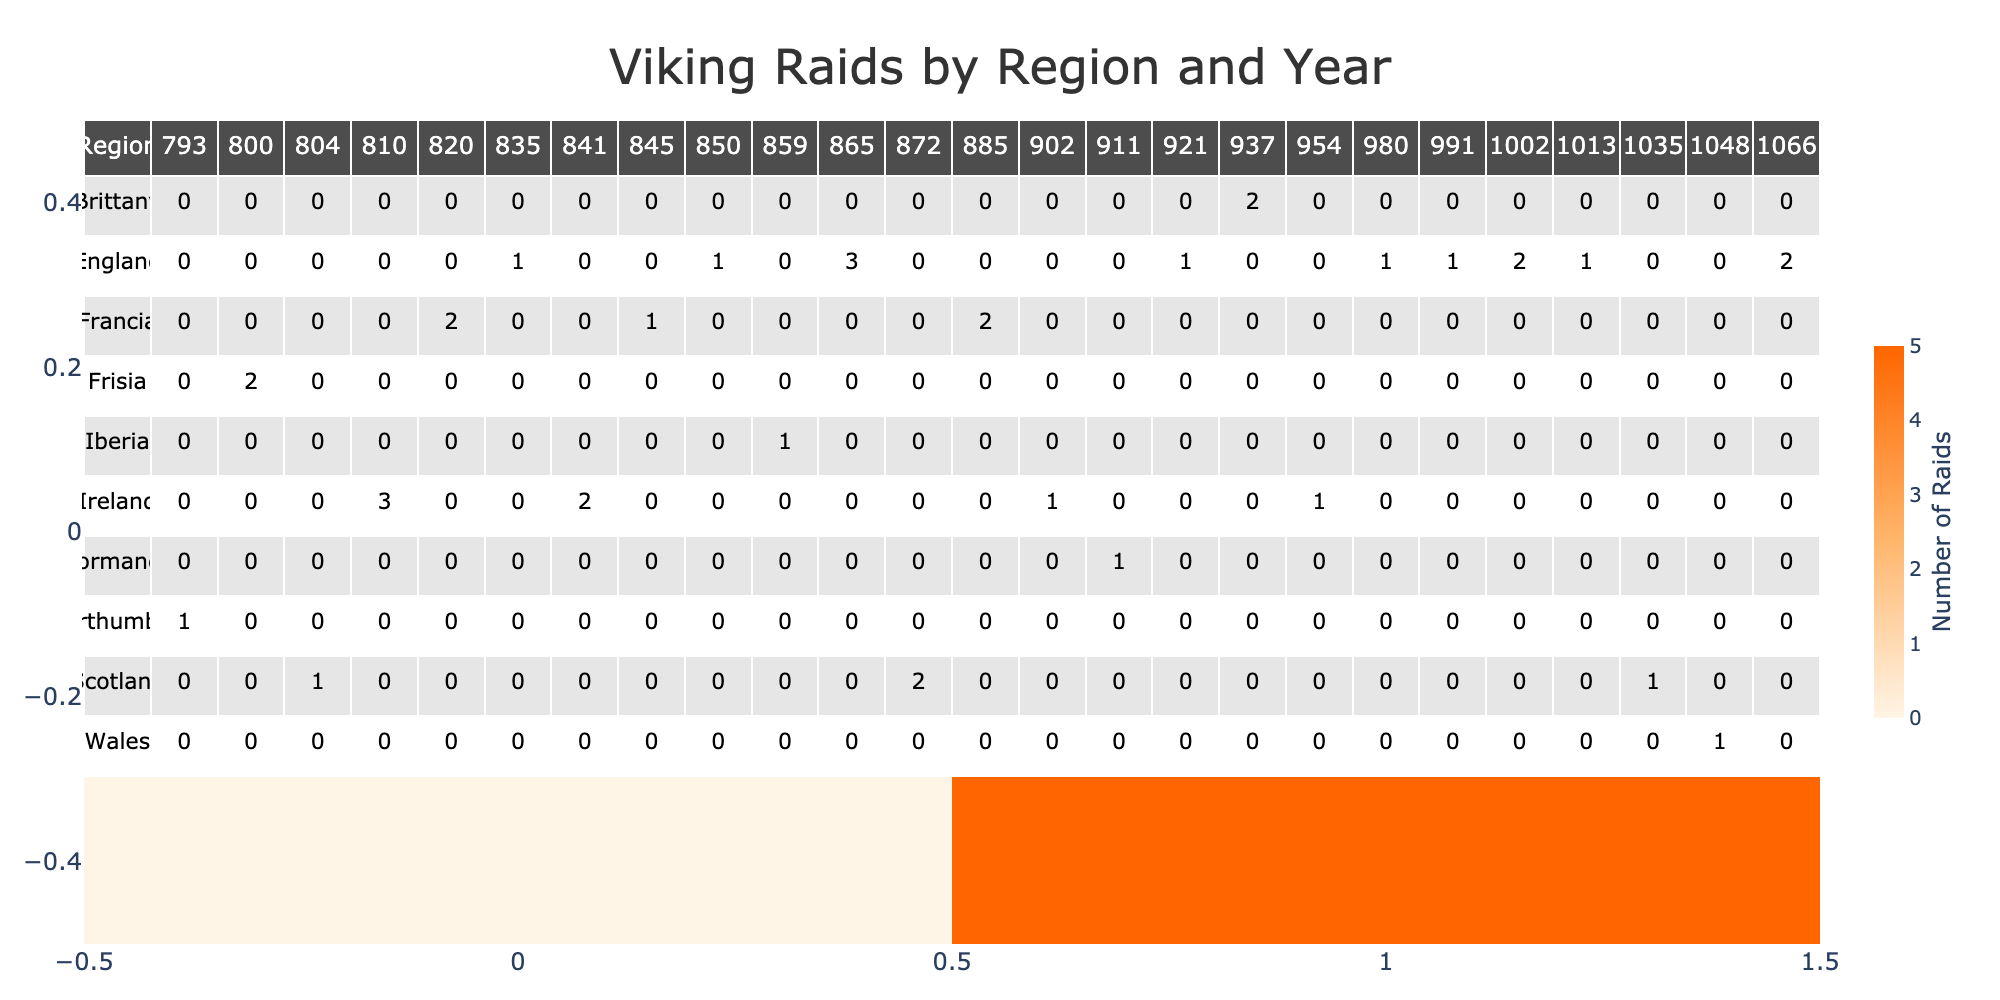What year had the highest number of raids recorded? By examining the table, we look at the "Number of Raids" for each year. The year 1066 shows a total of 2 raids, while other years have varying numbers, with 3 raids occurring in both 810 (Dublin) and 865 (East Anglia). The peak number of raids occurred in the year 1066 combined with an exceptionally high estimated Viking force and significant casualties.
Answer: 1066 Which region experienced the most raids in total? To find the region with the most raids, we sum all the raids for each region. Northumbria has 1, Frisia has 2, Scotland has 4, Ireland has 8, Francia has 5, England has 13, Iberia has 1, Normandy has 1, Brittany has 2, and Wales has 1. The total confirms that England experienced the most raids with 13.
Answer: England What was the average loot value of the raids recorded in Ireland? We examine the entries associated with Ireland: Dublin (12000), Cork (9000), Waterford (10000), Limerick (11000). The total loot value is 12000 + 9000 + 10000 + 11000 = 42000, and with 4 entries, the average is calculated as 42000 / 4 = 10500.
Answer: 10500 Did any region have a year in which the number of raids exceeded 3? Looking through the table, we find that Ireland in 810 and England in 865 both had years with 3 raids each. No other region had a year exceeding 3 raids, confirming that the claim of a year with more than 3 raids is false.
Answer: No What is the total number of casualties recorded from raids in Francia? We evaluate the casualties from the settlements in Francia: Paris (500), Rouen (400). Adding these together gives us 500 + 400 = 900. Therefore, the total is 900 casualties.
Answer: 900 In which year did the highest estimated Viking force appear, and what was that force? By searching through the "Estimated Viking Force" data, we see that 1066 featured the highest number at 8000. Thus, this was the year with the most significant Viking presence.
Answer: 1066, 8000 How many settlements were raided in England? We look at the entries related to England in the table: Isle of Sheppey, London, East Anglia, Stamford, Southampton, Maldon, Exeter, Canterbury, and York. That brings a total of 9 distinct settlements.
Answer: 9 Which region had the lowest loot value in a recorded raid, and what was that value? The entries show that in 793 for Lindisfarne in Northumbria, the loot value was 5000 marks, which is the lowest among all recorded values in the table.
Answer: Northumbria, 5000 